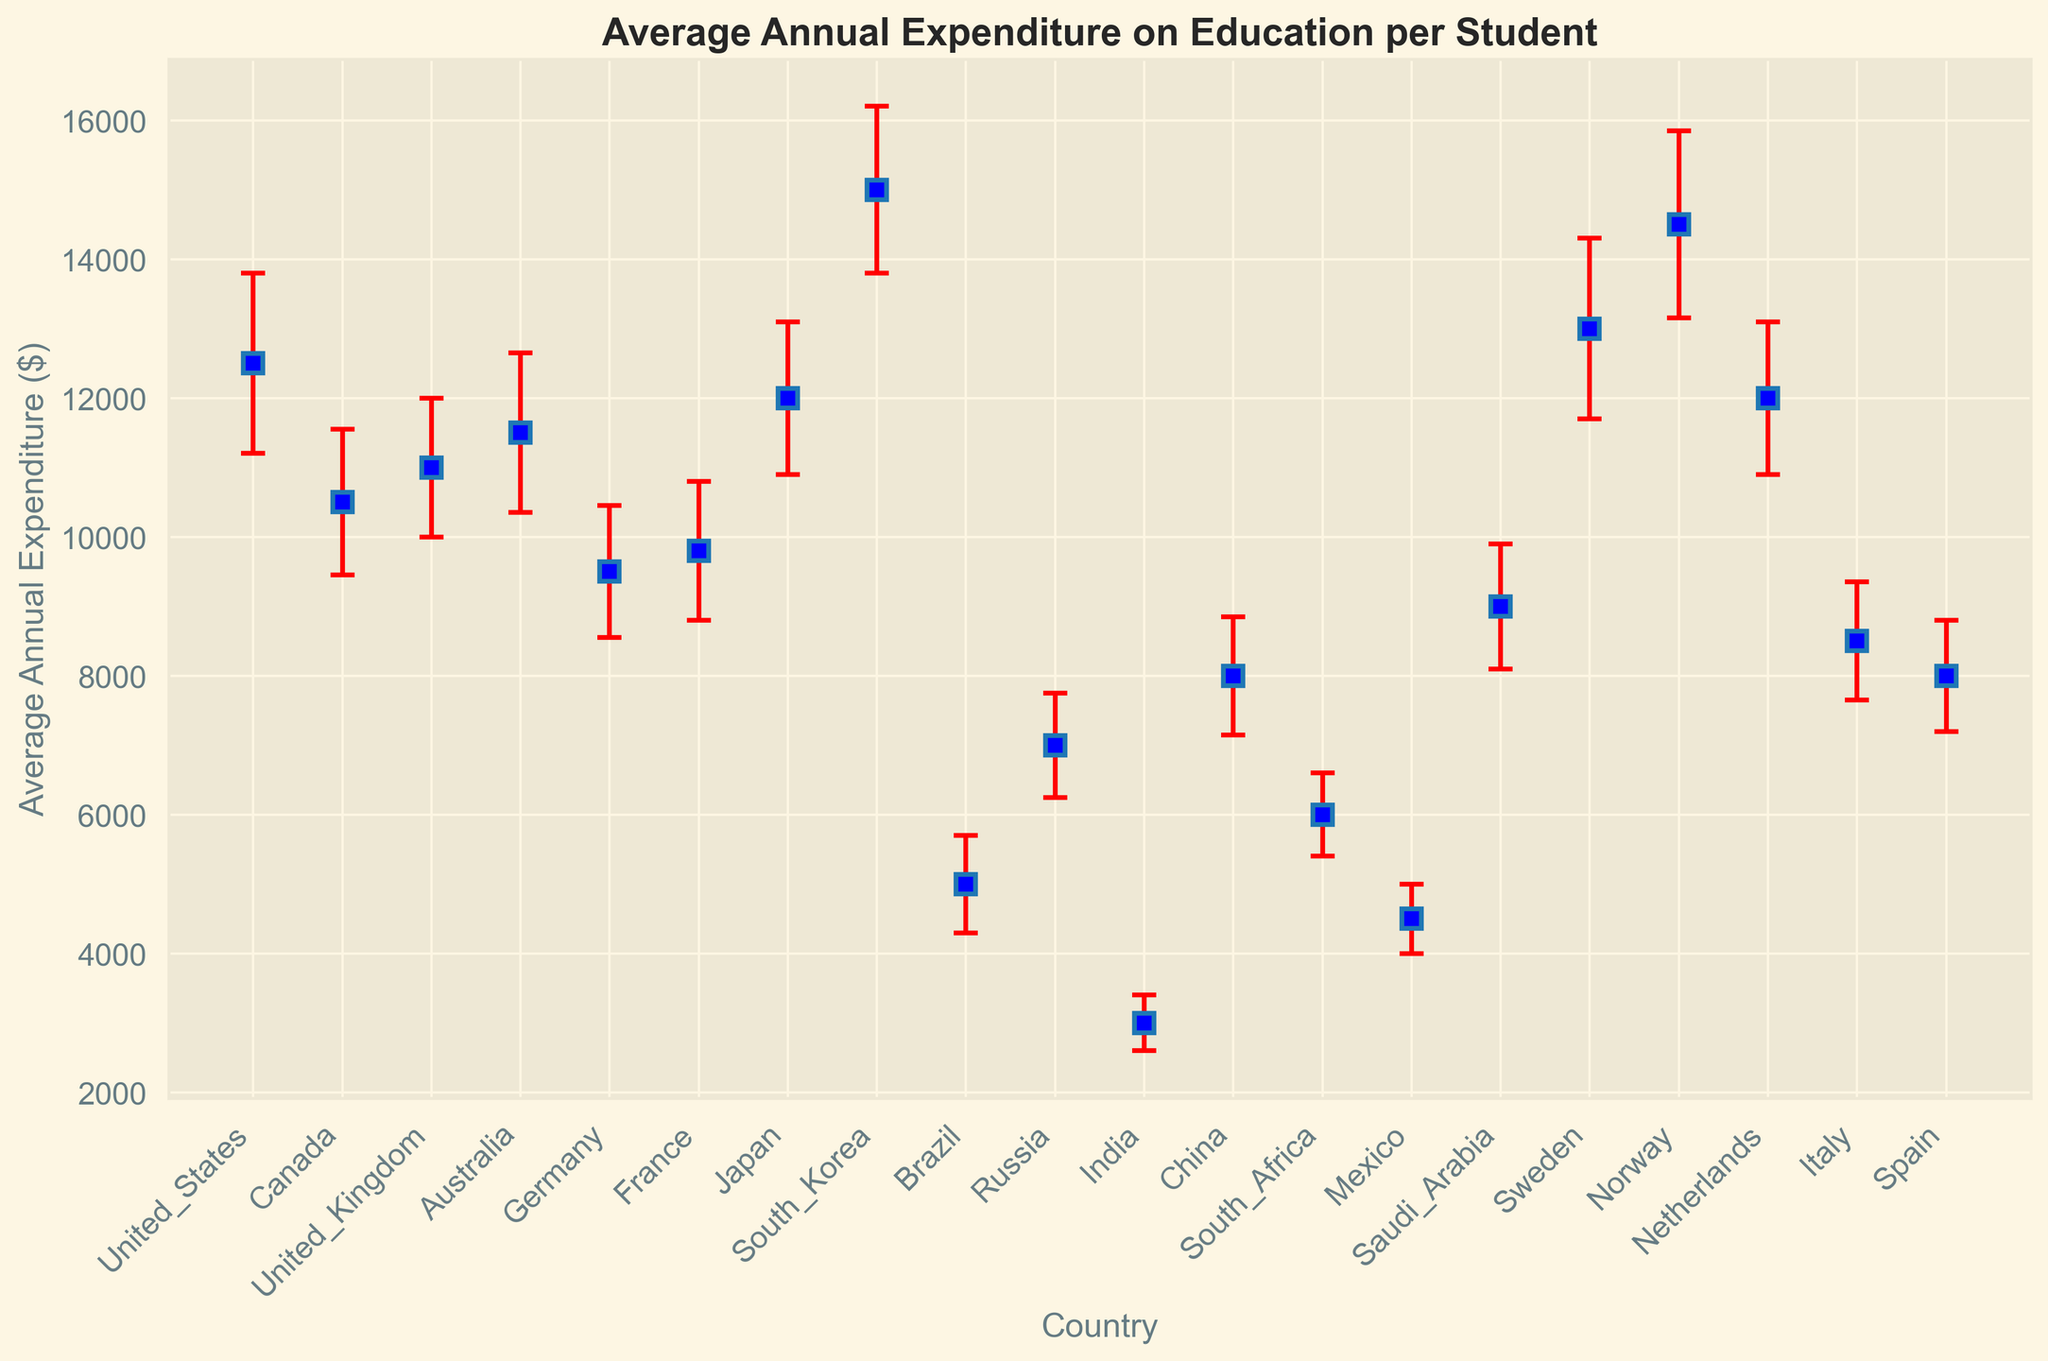Which country has the highest average annual expenditure on education per student? South Korea has the highest average annual expenditure on education per student at $15,000. This is determined by observing the highest data point on the graph.
Answer: South Korea Which country has the lowest average annual expenditure on education per student? India has the lowest average annual expenditure on education per student at $3,000. This is determined by observing the lowest data point on the graph.
Answer: India Which country has the largest standard deviation in average annual expenditure? Norway has the largest standard deviation in average annual expenditure with a value of $1,350. This is determined by the length of the error bars which represent the standard deviation. Norway's error bar is the longest.
Answer: Norway What's the difference in average annual expenditure between the country with the highest expenditure and the country with the lowest expenditure? The country with the highest expenditure is South Korea at $15,000, and the country with the lowest expenditure is India at $3,000. The difference is $15,000 - $3,000 = $12,000.
Answer: $12,000 Are any two countries spending exactly the same amount on education per student? By examining the data points on the graph, no two countries have the same average annual expenditure on education. Each country's expenditure is distinct based on the plotted points.
Answer: No Which country has a standard deviation exactly proportional to its average expenditure? Germany's standard deviation is $950, which is exactly one-tenth of its average expenditure of $9,500. This is identified by comparing the ratio of standard deviation to the average for all countries.
Answer: Germany How many countries have an average expenditure above $10,000? By counting the data points corresponding to countries with averages above $10,000, the countries are: United States, Canada, United Kingdom, Australia, Japan, South Korea, Sweden, Norway, Netherlands. There are 9 countries.
Answer: 9 Which country has roughly the same expenditure as the combined expenditure of Brazil and Mexico? Brazil's expenditure is $5,000 and Mexico's expenditure is $4,500. Combined, they total $9,500, which matches Germany's expenditure.
Answer: Germany How does the standard deviation of South Africa's expenditure compare to China's expenditure? South Africa's standard deviation is $600 and China's is $850. Thus, South Africa's standard deviation is $250 less than China's.
Answer: $250 less What percentage of Canada’s expenditure is South Africa's expenditure? Canada's expenditure is $10,500. South Africa's expenditure is $6,000. The percentage is calculated as (6000 / 10500) * 100 ≈ 57.14%.
Answer: ≈ 57.14% 